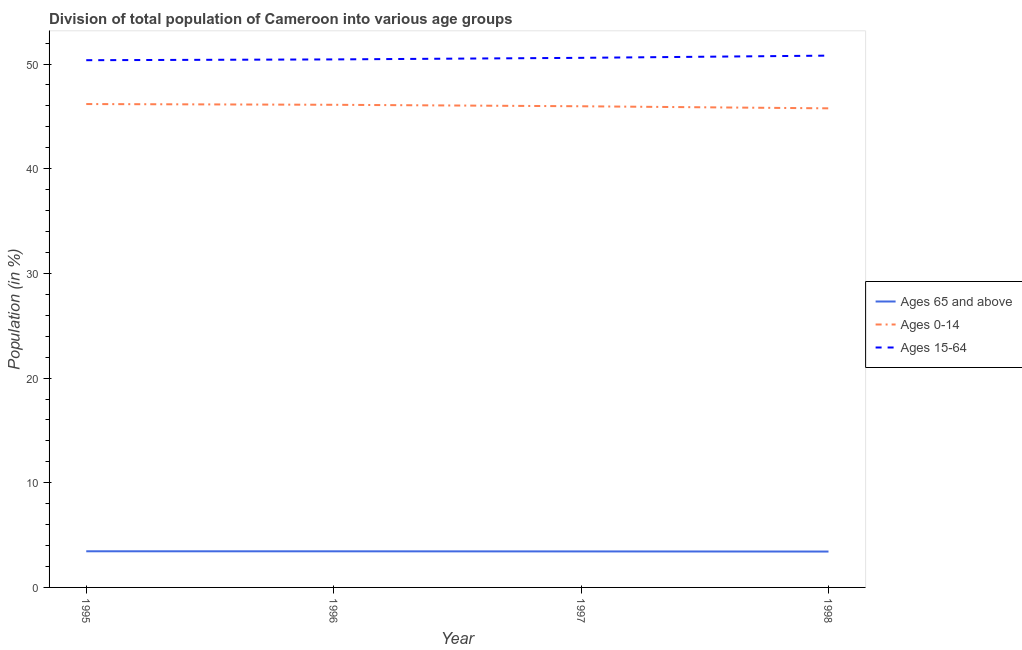How many different coloured lines are there?
Your response must be concise. 3. Does the line corresponding to percentage of population within the age-group of 65 and above intersect with the line corresponding to percentage of population within the age-group 0-14?
Give a very brief answer. No. Is the number of lines equal to the number of legend labels?
Provide a short and direct response. Yes. What is the percentage of population within the age-group 0-14 in 1995?
Provide a short and direct response. 46.18. Across all years, what is the maximum percentage of population within the age-group of 65 and above?
Offer a very short reply. 3.45. Across all years, what is the minimum percentage of population within the age-group of 65 and above?
Offer a terse response. 3.43. What is the total percentage of population within the age-group 0-14 in the graph?
Offer a terse response. 184.02. What is the difference between the percentage of population within the age-group of 65 and above in 1997 and that in 1998?
Ensure brevity in your answer.  0.01. What is the difference between the percentage of population within the age-group 0-14 in 1997 and the percentage of population within the age-group 15-64 in 1996?
Ensure brevity in your answer.  -4.48. What is the average percentage of population within the age-group of 65 and above per year?
Offer a very short reply. 3.44. In the year 1995, what is the difference between the percentage of population within the age-group 0-14 and percentage of population within the age-group of 65 and above?
Make the answer very short. 42.73. In how many years, is the percentage of population within the age-group 15-64 greater than 2 %?
Your answer should be compact. 4. What is the ratio of the percentage of population within the age-group 0-14 in 1995 to that in 1996?
Offer a very short reply. 1. Is the percentage of population within the age-group of 65 and above in 1995 less than that in 1997?
Offer a very short reply. No. Is the difference between the percentage of population within the age-group of 65 and above in 1996 and 1998 greater than the difference between the percentage of population within the age-group 0-14 in 1996 and 1998?
Offer a very short reply. No. What is the difference between the highest and the second highest percentage of population within the age-group of 65 and above?
Offer a terse response. 0. What is the difference between the highest and the lowest percentage of population within the age-group 0-14?
Your answer should be very brief. 0.41. In how many years, is the percentage of population within the age-group 15-64 greater than the average percentage of population within the age-group 15-64 taken over all years?
Make the answer very short. 2. Is the sum of the percentage of population within the age-group of 65 and above in 1996 and 1997 greater than the maximum percentage of population within the age-group 0-14 across all years?
Make the answer very short. No. Is the percentage of population within the age-group 0-14 strictly greater than the percentage of population within the age-group 15-64 over the years?
Keep it short and to the point. No. Is the percentage of population within the age-group of 65 and above strictly less than the percentage of population within the age-group 15-64 over the years?
Provide a succinct answer. Yes. How many lines are there?
Your response must be concise. 3. How many years are there in the graph?
Provide a short and direct response. 4. Are the values on the major ticks of Y-axis written in scientific E-notation?
Your answer should be very brief. No. Where does the legend appear in the graph?
Provide a short and direct response. Center right. How many legend labels are there?
Give a very brief answer. 3. What is the title of the graph?
Keep it short and to the point. Division of total population of Cameroon into various age groups
. What is the Population (in %) in Ages 65 and above in 1995?
Provide a succinct answer. 3.45. What is the Population (in %) in Ages 0-14 in 1995?
Your answer should be very brief. 46.18. What is the Population (in %) in Ages 15-64 in 1995?
Offer a very short reply. 50.37. What is the Population (in %) in Ages 65 and above in 1996?
Keep it short and to the point. 3.45. What is the Population (in %) of Ages 0-14 in 1996?
Keep it short and to the point. 46.11. What is the Population (in %) of Ages 15-64 in 1996?
Give a very brief answer. 50.44. What is the Population (in %) in Ages 65 and above in 1997?
Make the answer very short. 3.44. What is the Population (in %) in Ages 0-14 in 1997?
Ensure brevity in your answer.  45.97. What is the Population (in %) of Ages 15-64 in 1997?
Your answer should be compact. 50.59. What is the Population (in %) of Ages 65 and above in 1998?
Offer a terse response. 3.43. What is the Population (in %) in Ages 0-14 in 1998?
Your answer should be compact. 45.77. What is the Population (in %) in Ages 15-64 in 1998?
Your answer should be very brief. 50.8. Across all years, what is the maximum Population (in %) of Ages 65 and above?
Provide a short and direct response. 3.45. Across all years, what is the maximum Population (in %) in Ages 0-14?
Provide a short and direct response. 46.18. Across all years, what is the maximum Population (in %) of Ages 15-64?
Your response must be concise. 50.8. Across all years, what is the minimum Population (in %) in Ages 65 and above?
Make the answer very short. 3.43. Across all years, what is the minimum Population (in %) in Ages 0-14?
Your answer should be compact. 45.77. Across all years, what is the minimum Population (in %) in Ages 15-64?
Your answer should be very brief. 50.37. What is the total Population (in %) of Ages 65 and above in the graph?
Offer a very short reply. 13.77. What is the total Population (in %) of Ages 0-14 in the graph?
Give a very brief answer. 184.02. What is the total Population (in %) in Ages 15-64 in the graph?
Keep it short and to the point. 202.21. What is the difference between the Population (in %) of Ages 65 and above in 1995 and that in 1996?
Your answer should be compact. 0. What is the difference between the Population (in %) of Ages 0-14 in 1995 and that in 1996?
Ensure brevity in your answer.  0.07. What is the difference between the Population (in %) of Ages 15-64 in 1995 and that in 1996?
Make the answer very short. -0.07. What is the difference between the Population (in %) in Ages 65 and above in 1995 and that in 1997?
Make the answer very short. 0.01. What is the difference between the Population (in %) of Ages 0-14 in 1995 and that in 1997?
Make the answer very short. 0.21. What is the difference between the Population (in %) in Ages 15-64 in 1995 and that in 1997?
Provide a short and direct response. -0.23. What is the difference between the Population (in %) of Ages 65 and above in 1995 and that in 1998?
Your answer should be compact. 0.03. What is the difference between the Population (in %) of Ages 0-14 in 1995 and that in 1998?
Your answer should be very brief. 0.41. What is the difference between the Population (in %) in Ages 15-64 in 1995 and that in 1998?
Your answer should be compact. -0.44. What is the difference between the Population (in %) of Ages 65 and above in 1996 and that in 1997?
Provide a short and direct response. 0.01. What is the difference between the Population (in %) in Ages 0-14 in 1996 and that in 1997?
Ensure brevity in your answer.  0.14. What is the difference between the Population (in %) of Ages 15-64 in 1996 and that in 1997?
Provide a succinct answer. -0.15. What is the difference between the Population (in %) in Ages 65 and above in 1996 and that in 1998?
Your answer should be compact. 0.02. What is the difference between the Population (in %) of Ages 0-14 in 1996 and that in 1998?
Ensure brevity in your answer.  0.34. What is the difference between the Population (in %) in Ages 15-64 in 1996 and that in 1998?
Give a very brief answer. -0.36. What is the difference between the Population (in %) of Ages 65 and above in 1997 and that in 1998?
Offer a terse response. 0.01. What is the difference between the Population (in %) of Ages 0-14 in 1997 and that in 1998?
Offer a terse response. 0.2. What is the difference between the Population (in %) in Ages 15-64 in 1997 and that in 1998?
Your answer should be very brief. -0.21. What is the difference between the Population (in %) of Ages 65 and above in 1995 and the Population (in %) of Ages 0-14 in 1996?
Provide a succinct answer. -42.65. What is the difference between the Population (in %) of Ages 65 and above in 1995 and the Population (in %) of Ages 15-64 in 1996?
Your answer should be very brief. -46.99. What is the difference between the Population (in %) in Ages 0-14 in 1995 and the Population (in %) in Ages 15-64 in 1996?
Keep it short and to the point. -4.26. What is the difference between the Population (in %) in Ages 65 and above in 1995 and the Population (in %) in Ages 0-14 in 1997?
Offer a terse response. -42.51. What is the difference between the Population (in %) of Ages 65 and above in 1995 and the Population (in %) of Ages 15-64 in 1997?
Give a very brief answer. -47.14. What is the difference between the Population (in %) in Ages 0-14 in 1995 and the Population (in %) in Ages 15-64 in 1997?
Your answer should be very brief. -4.41. What is the difference between the Population (in %) in Ages 65 and above in 1995 and the Population (in %) in Ages 0-14 in 1998?
Give a very brief answer. -42.31. What is the difference between the Population (in %) of Ages 65 and above in 1995 and the Population (in %) of Ages 15-64 in 1998?
Give a very brief answer. -47.35. What is the difference between the Population (in %) of Ages 0-14 in 1995 and the Population (in %) of Ages 15-64 in 1998?
Make the answer very short. -4.63. What is the difference between the Population (in %) in Ages 65 and above in 1996 and the Population (in %) in Ages 0-14 in 1997?
Provide a short and direct response. -42.52. What is the difference between the Population (in %) of Ages 65 and above in 1996 and the Population (in %) of Ages 15-64 in 1997?
Ensure brevity in your answer.  -47.14. What is the difference between the Population (in %) in Ages 0-14 in 1996 and the Population (in %) in Ages 15-64 in 1997?
Your response must be concise. -4.48. What is the difference between the Population (in %) of Ages 65 and above in 1996 and the Population (in %) of Ages 0-14 in 1998?
Your answer should be very brief. -42.32. What is the difference between the Population (in %) of Ages 65 and above in 1996 and the Population (in %) of Ages 15-64 in 1998?
Your answer should be very brief. -47.36. What is the difference between the Population (in %) in Ages 0-14 in 1996 and the Population (in %) in Ages 15-64 in 1998?
Your response must be concise. -4.7. What is the difference between the Population (in %) in Ages 65 and above in 1997 and the Population (in %) in Ages 0-14 in 1998?
Make the answer very short. -42.33. What is the difference between the Population (in %) of Ages 65 and above in 1997 and the Population (in %) of Ages 15-64 in 1998?
Provide a short and direct response. -47.36. What is the difference between the Population (in %) of Ages 0-14 in 1997 and the Population (in %) of Ages 15-64 in 1998?
Keep it short and to the point. -4.84. What is the average Population (in %) of Ages 65 and above per year?
Your response must be concise. 3.44. What is the average Population (in %) of Ages 0-14 per year?
Offer a terse response. 46.01. What is the average Population (in %) of Ages 15-64 per year?
Your answer should be compact. 50.55. In the year 1995, what is the difference between the Population (in %) of Ages 65 and above and Population (in %) of Ages 0-14?
Ensure brevity in your answer.  -42.73. In the year 1995, what is the difference between the Population (in %) of Ages 65 and above and Population (in %) of Ages 15-64?
Provide a succinct answer. -46.91. In the year 1995, what is the difference between the Population (in %) in Ages 0-14 and Population (in %) in Ages 15-64?
Your answer should be compact. -4.19. In the year 1996, what is the difference between the Population (in %) of Ages 65 and above and Population (in %) of Ages 0-14?
Provide a succinct answer. -42.66. In the year 1996, what is the difference between the Population (in %) in Ages 65 and above and Population (in %) in Ages 15-64?
Your answer should be very brief. -46.99. In the year 1996, what is the difference between the Population (in %) in Ages 0-14 and Population (in %) in Ages 15-64?
Your answer should be very brief. -4.33. In the year 1997, what is the difference between the Population (in %) of Ages 65 and above and Population (in %) of Ages 0-14?
Give a very brief answer. -42.53. In the year 1997, what is the difference between the Population (in %) of Ages 65 and above and Population (in %) of Ages 15-64?
Ensure brevity in your answer.  -47.15. In the year 1997, what is the difference between the Population (in %) of Ages 0-14 and Population (in %) of Ages 15-64?
Offer a very short reply. -4.63. In the year 1998, what is the difference between the Population (in %) in Ages 65 and above and Population (in %) in Ages 0-14?
Provide a succinct answer. -42.34. In the year 1998, what is the difference between the Population (in %) in Ages 65 and above and Population (in %) in Ages 15-64?
Ensure brevity in your answer.  -47.38. In the year 1998, what is the difference between the Population (in %) in Ages 0-14 and Population (in %) in Ages 15-64?
Give a very brief answer. -5.04. What is the ratio of the Population (in %) in Ages 65 and above in 1995 to that in 1996?
Give a very brief answer. 1. What is the ratio of the Population (in %) of Ages 0-14 in 1995 to that in 1996?
Offer a terse response. 1. What is the ratio of the Population (in %) of Ages 65 and above in 1995 to that in 1998?
Give a very brief answer. 1.01. What is the ratio of the Population (in %) in Ages 0-14 in 1995 to that in 1998?
Make the answer very short. 1.01. What is the ratio of the Population (in %) in Ages 15-64 in 1995 to that in 1998?
Give a very brief answer. 0.99. What is the ratio of the Population (in %) of Ages 15-64 in 1996 to that in 1997?
Give a very brief answer. 1. What is the ratio of the Population (in %) of Ages 65 and above in 1996 to that in 1998?
Your response must be concise. 1.01. What is the ratio of the Population (in %) of Ages 0-14 in 1996 to that in 1998?
Ensure brevity in your answer.  1.01. What is the ratio of the Population (in %) in Ages 65 and above in 1997 to that in 1998?
Provide a succinct answer. 1. What is the ratio of the Population (in %) in Ages 15-64 in 1997 to that in 1998?
Offer a terse response. 1. What is the difference between the highest and the second highest Population (in %) in Ages 65 and above?
Your answer should be compact. 0. What is the difference between the highest and the second highest Population (in %) in Ages 0-14?
Your answer should be compact. 0.07. What is the difference between the highest and the second highest Population (in %) of Ages 15-64?
Your answer should be very brief. 0.21. What is the difference between the highest and the lowest Population (in %) of Ages 65 and above?
Keep it short and to the point. 0.03. What is the difference between the highest and the lowest Population (in %) in Ages 0-14?
Give a very brief answer. 0.41. What is the difference between the highest and the lowest Population (in %) of Ages 15-64?
Provide a short and direct response. 0.44. 